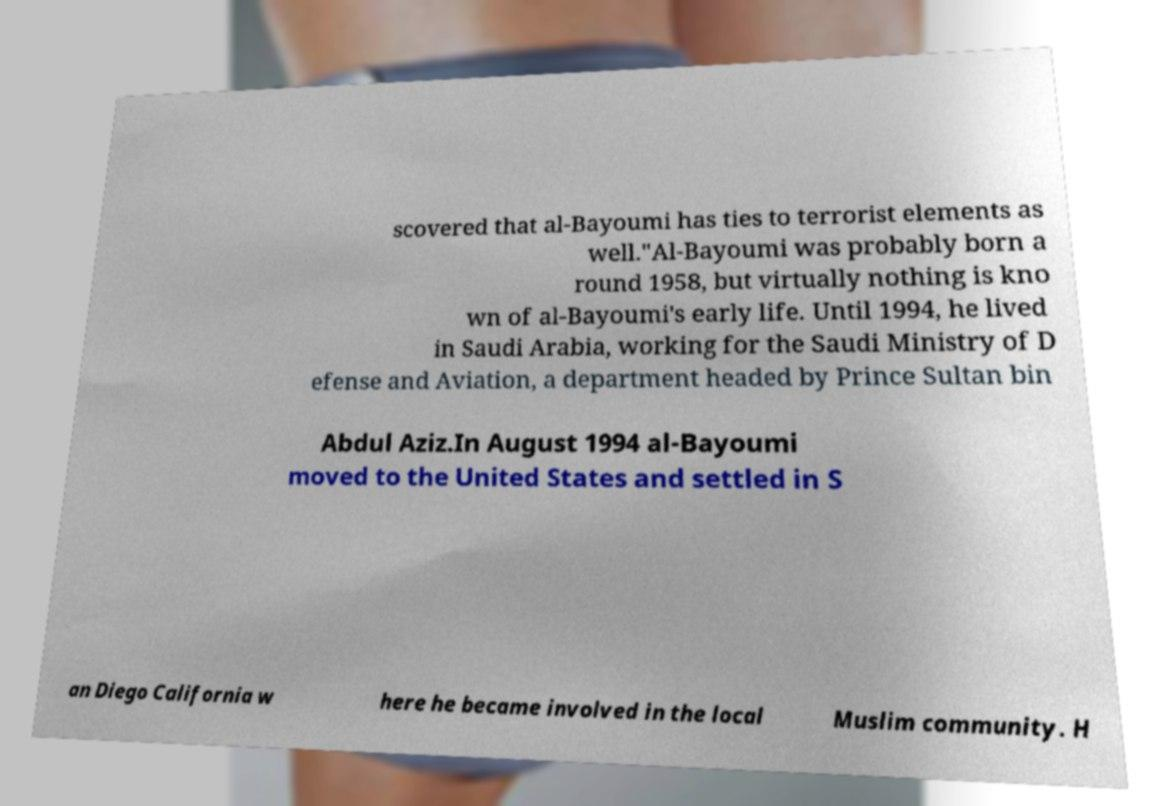For documentation purposes, I need the text within this image transcribed. Could you provide that? scovered that al-Bayoumi has ties to terrorist elements as well."Al-Bayoumi was probably born a round 1958, but virtually nothing is kno wn of al-Bayoumi's early life. Until 1994, he lived in Saudi Arabia, working for the Saudi Ministry of D efense and Aviation, a department headed by Prince Sultan bin Abdul Aziz.In August 1994 al-Bayoumi moved to the United States and settled in S an Diego California w here he became involved in the local Muslim community. H 